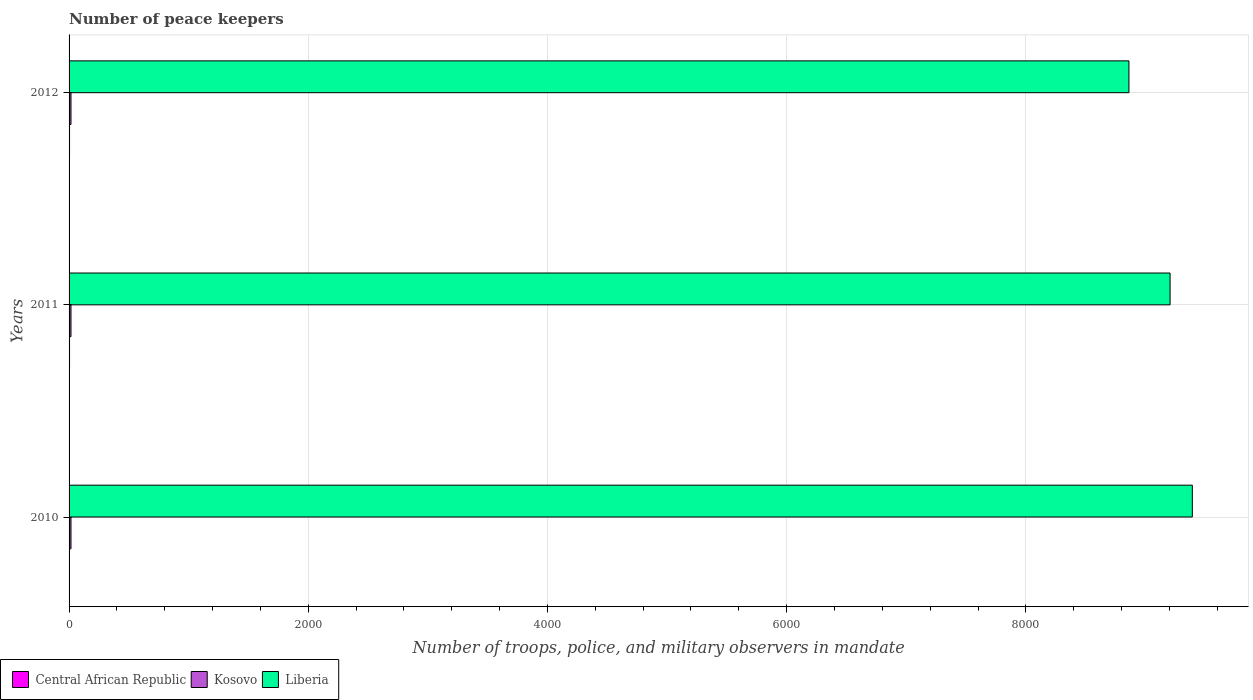How many different coloured bars are there?
Offer a very short reply. 3. How many bars are there on the 1st tick from the top?
Your response must be concise. 3. What is the number of peace keepers in in Liberia in 2011?
Provide a short and direct response. 9206. Across all years, what is the maximum number of peace keepers in in Liberia?
Provide a succinct answer. 9392. In which year was the number of peace keepers in in Central African Republic maximum?
Provide a succinct answer. 2011. What is the total number of peace keepers in in Liberia in the graph?
Offer a terse response. 2.75e+04. What is the difference between the number of peace keepers in in Liberia in 2011 and that in 2012?
Make the answer very short. 344. What is the difference between the number of peace keepers in in Liberia in 2010 and the number of peace keepers in in Central African Republic in 2011?
Your answer should be very brief. 9388. What is the average number of peace keepers in in Liberia per year?
Provide a short and direct response. 9153.33. In the year 2011, what is the difference between the number of peace keepers in in Central African Republic and number of peace keepers in in Liberia?
Provide a short and direct response. -9202. In how many years, is the number of peace keepers in in Liberia greater than 6000 ?
Offer a terse response. 3. What is the ratio of the number of peace keepers in in Central African Republic in 2011 to that in 2012?
Your answer should be very brief. 1. Is the number of peace keepers in in Liberia in 2010 less than that in 2012?
Give a very brief answer. No. What is the difference between the highest and the second highest number of peace keepers in in Liberia?
Offer a terse response. 186. What is the difference between the highest and the lowest number of peace keepers in in Central African Republic?
Provide a short and direct response. 1. What does the 1st bar from the top in 2012 represents?
Provide a short and direct response. Liberia. What does the 3rd bar from the bottom in 2012 represents?
Your response must be concise. Liberia. Is it the case that in every year, the sum of the number of peace keepers in in Central African Republic and number of peace keepers in in Kosovo is greater than the number of peace keepers in in Liberia?
Give a very brief answer. No. How many bars are there?
Your answer should be very brief. 9. Are all the bars in the graph horizontal?
Offer a terse response. Yes. How many years are there in the graph?
Offer a very short reply. 3. What is the difference between two consecutive major ticks on the X-axis?
Offer a terse response. 2000. Does the graph contain grids?
Give a very brief answer. Yes. How many legend labels are there?
Make the answer very short. 3. What is the title of the graph?
Your answer should be compact. Number of peace keepers. Does "Thailand" appear as one of the legend labels in the graph?
Provide a succinct answer. No. What is the label or title of the X-axis?
Offer a very short reply. Number of troops, police, and military observers in mandate. What is the label or title of the Y-axis?
Make the answer very short. Years. What is the Number of troops, police, and military observers in mandate of Central African Republic in 2010?
Offer a very short reply. 3. What is the Number of troops, police, and military observers in mandate of Liberia in 2010?
Ensure brevity in your answer.  9392. What is the Number of troops, police, and military observers in mandate in Central African Republic in 2011?
Ensure brevity in your answer.  4. What is the Number of troops, police, and military observers in mandate in Kosovo in 2011?
Make the answer very short. 16. What is the Number of troops, police, and military observers in mandate in Liberia in 2011?
Offer a terse response. 9206. What is the Number of troops, police, and military observers in mandate of Central African Republic in 2012?
Provide a short and direct response. 4. What is the Number of troops, police, and military observers in mandate of Liberia in 2012?
Provide a short and direct response. 8862. Across all years, what is the maximum Number of troops, police, and military observers in mandate of Liberia?
Keep it short and to the point. 9392. Across all years, what is the minimum Number of troops, police, and military observers in mandate of Central African Republic?
Keep it short and to the point. 3. Across all years, what is the minimum Number of troops, police, and military observers in mandate in Kosovo?
Your answer should be very brief. 16. Across all years, what is the minimum Number of troops, police, and military observers in mandate of Liberia?
Provide a succinct answer. 8862. What is the total Number of troops, police, and military observers in mandate of Liberia in the graph?
Your answer should be very brief. 2.75e+04. What is the difference between the Number of troops, police, and military observers in mandate of Central African Republic in 2010 and that in 2011?
Your answer should be very brief. -1. What is the difference between the Number of troops, police, and military observers in mandate in Kosovo in 2010 and that in 2011?
Make the answer very short. 0. What is the difference between the Number of troops, police, and military observers in mandate of Liberia in 2010 and that in 2011?
Provide a succinct answer. 186. What is the difference between the Number of troops, police, and military observers in mandate in Liberia in 2010 and that in 2012?
Give a very brief answer. 530. What is the difference between the Number of troops, police, and military observers in mandate of Liberia in 2011 and that in 2012?
Ensure brevity in your answer.  344. What is the difference between the Number of troops, police, and military observers in mandate in Central African Republic in 2010 and the Number of troops, police, and military observers in mandate in Liberia in 2011?
Offer a terse response. -9203. What is the difference between the Number of troops, police, and military observers in mandate of Kosovo in 2010 and the Number of troops, police, and military observers in mandate of Liberia in 2011?
Give a very brief answer. -9190. What is the difference between the Number of troops, police, and military observers in mandate in Central African Republic in 2010 and the Number of troops, police, and military observers in mandate in Liberia in 2012?
Provide a succinct answer. -8859. What is the difference between the Number of troops, police, and military observers in mandate in Kosovo in 2010 and the Number of troops, police, and military observers in mandate in Liberia in 2012?
Give a very brief answer. -8846. What is the difference between the Number of troops, police, and military observers in mandate of Central African Republic in 2011 and the Number of troops, police, and military observers in mandate of Kosovo in 2012?
Your response must be concise. -12. What is the difference between the Number of troops, police, and military observers in mandate in Central African Republic in 2011 and the Number of troops, police, and military observers in mandate in Liberia in 2012?
Provide a succinct answer. -8858. What is the difference between the Number of troops, police, and military observers in mandate in Kosovo in 2011 and the Number of troops, police, and military observers in mandate in Liberia in 2012?
Give a very brief answer. -8846. What is the average Number of troops, police, and military observers in mandate of Central African Republic per year?
Make the answer very short. 3.67. What is the average Number of troops, police, and military observers in mandate of Liberia per year?
Your answer should be very brief. 9153.33. In the year 2010, what is the difference between the Number of troops, police, and military observers in mandate of Central African Republic and Number of troops, police, and military observers in mandate of Liberia?
Provide a short and direct response. -9389. In the year 2010, what is the difference between the Number of troops, police, and military observers in mandate of Kosovo and Number of troops, police, and military observers in mandate of Liberia?
Ensure brevity in your answer.  -9376. In the year 2011, what is the difference between the Number of troops, police, and military observers in mandate in Central African Republic and Number of troops, police, and military observers in mandate in Liberia?
Offer a terse response. -9202. In the year 2011, what is the difference between the Number of troops, police, and military observers in mandate in Kosovo and Number of troops, police, and military observers in mandate in Liberia?
Make the answer very short. -9190. In the year 2012, what is the difference between the Number of troops, police, and military observers in mandate of Central African Republic and Number of troops, police, and military observers in mandate of Kosovo?
Offer a very short reply. -12. In the year 2012, what is the difference between the Number of troops, police, and military observers in mandate of Central African Republic and Number of troops, police, and military observers in mandate of Liberia?
Offer a terse response. -8858. In the year 2012, what is the difference between the Number of troops, police, and military observers in mandate in Kosovo and Number of troops, police, and military observers in mandate in Liberia?
Offer a very short reply. -8846. What is the ratio of the Number of troops, police, and military observers in mandate in Liberia in 2010 to that in 2011?
Ensure brevity in your answer.  1.02. What is the ratio of the Number of troops, police, and military observers in mandate of Central African Republic in 2010 to that in 2012?
Make the answer very short. 0.75. What is the ratio of the Number of troops, police, and military observers in mandate in Kosovo in 2010 to that in 2012?
Ensure brevity in your answer.  1. What is the ratio of the Number of troops, police, and military observers in mandate in Liberia in 2010 to that in 2012?
Offer a terse response. 1.06. What is the ratio of the Number of troops, police, and military observers in mandate of Central African Republic in 2011 to that in 2012?
Offer a terse response. 1. What is the ratio of the Number of troops, police, and military observers in mandate in Liberia in 2011 to that in 2012?
Offer a terse response. 1.04. What is the difference between the highest and the second highest Number of troops, police, and military observers in mandate in Liberia?
Your answer should be compact. 186. What is the difference between the highest and the lowest Number of troops, police, and military observers in mandate in Liberia?
Keep it short and to the point. 530. 